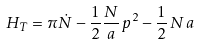Convert formula to latex. <formula><loc_0><loc_0><loc_500><loc_500>H _ { T } = \pi \dot { N } - \frac { 1 } { 2 } \frac { N } { a } \, p ^ { 2 } - \frac { 1 } { 2 } \, N \, a</formula> 